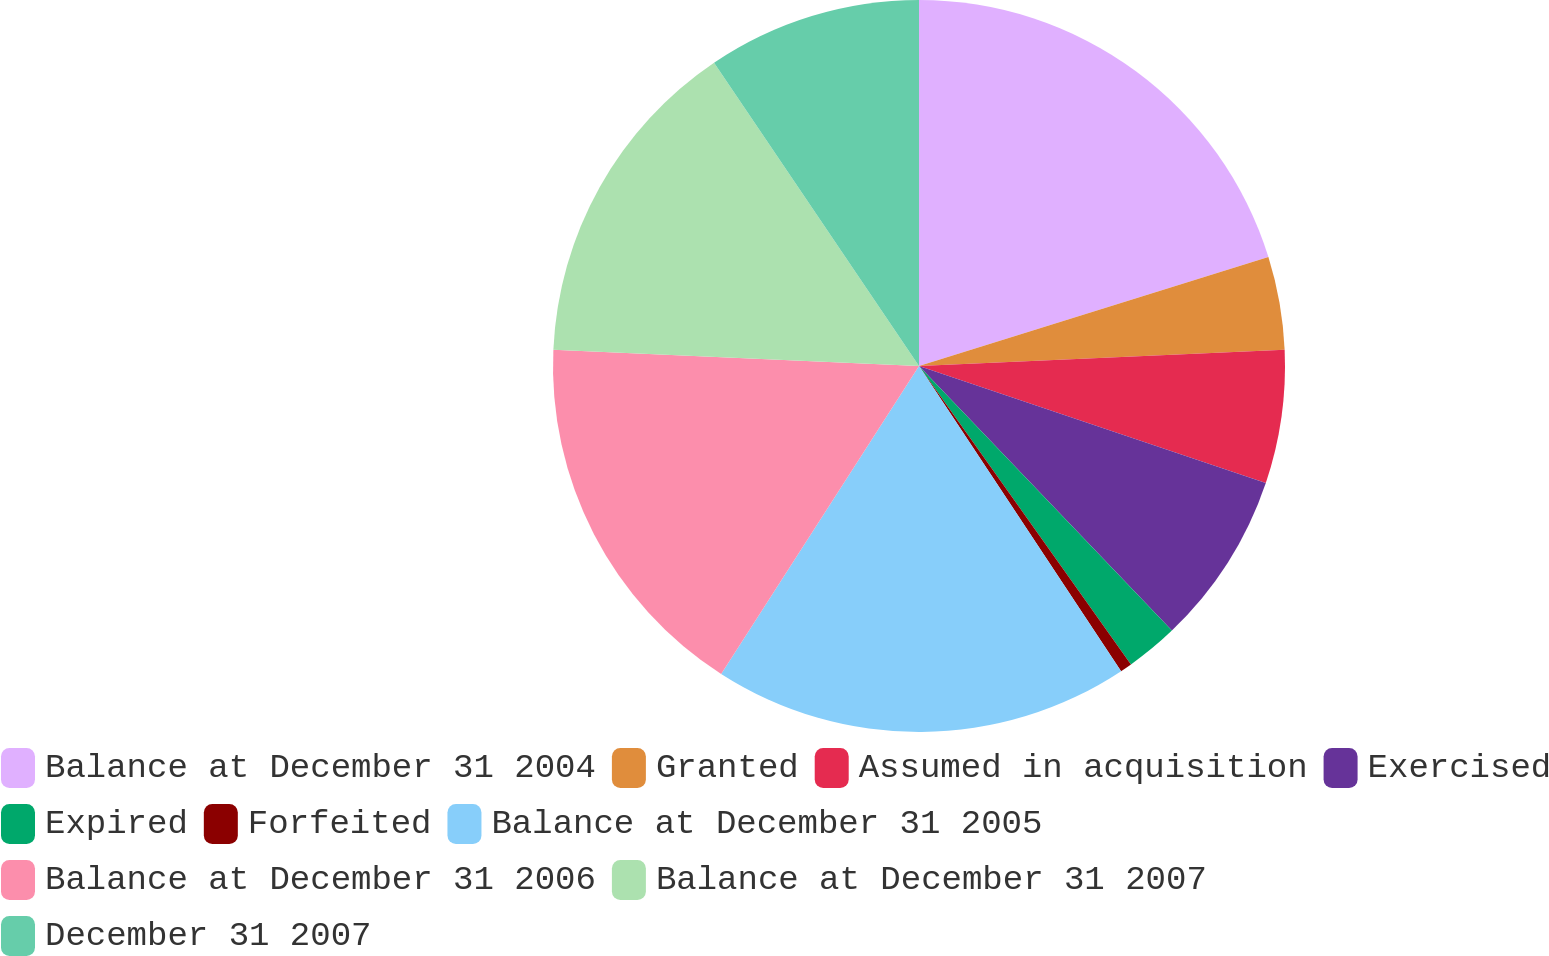Convert chart. <chart><loc_0><loc_0><loc_500><loc_500><pie_chart><fcel>Balance at December 31 2004<fcel>Granted<fcel>Assumed in acquisition<fcel>Exercised<fcel>Expired<fcel>Forfeited<fcel>Balance at December 31 2005<fcel>Balance at December 31 2006<fcel>Balance at December 31 2007<fcel>December 31 2007<nl><fcel>20.19%<fcel>4.1%<fcel>5.89%<fcel>7.68%<fcel>2.31%<fcel>0.52%<fcel>18.4%<fcel>16.62%<fcel>14.83%<fcel>9.46%<nl></chart> 